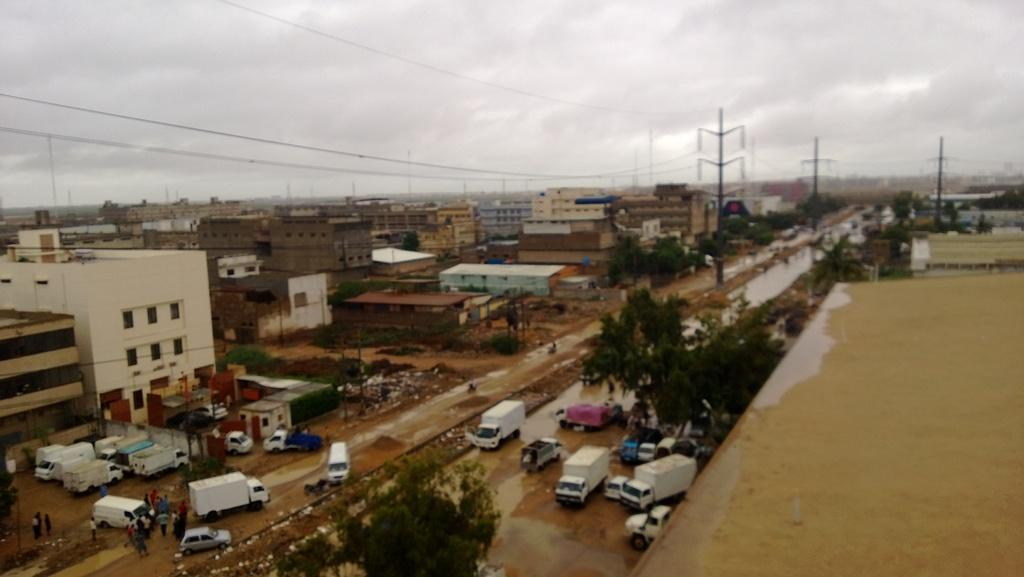What can be seen on the road in the image? There are vehicles on the road in the image. Who or what else is present in the image? There is a group of people in the image. What type of natural elements can be seen in the image? There are trees in the image. What type of man-made structures are visible in the image? There are buildings in the image. What type of infrastructure can be seen in the image? There are poles and cables in the image. What type of water is visible in the image? There is water visible in the image. What can be seen in the background of the image? The sky is visible in the background of the image. What type of calculator is being used by the group of people in the image? There is no calculator present in the image. What type of table is visible in the image? There is no table visible in the image. 